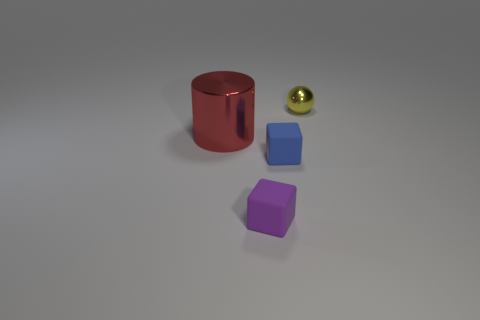What's the possible arrangement pattern or purpose of these objects? While the objects seem randomly placed, they could be arranged for a visual comparison of geometry and color. They exhibit primary shapes – a cylinder, cubes, and sphere – which might be used in an educational setting to teach about forms, or in a design context to evaluate lighting and texture effects on different surfaces. 